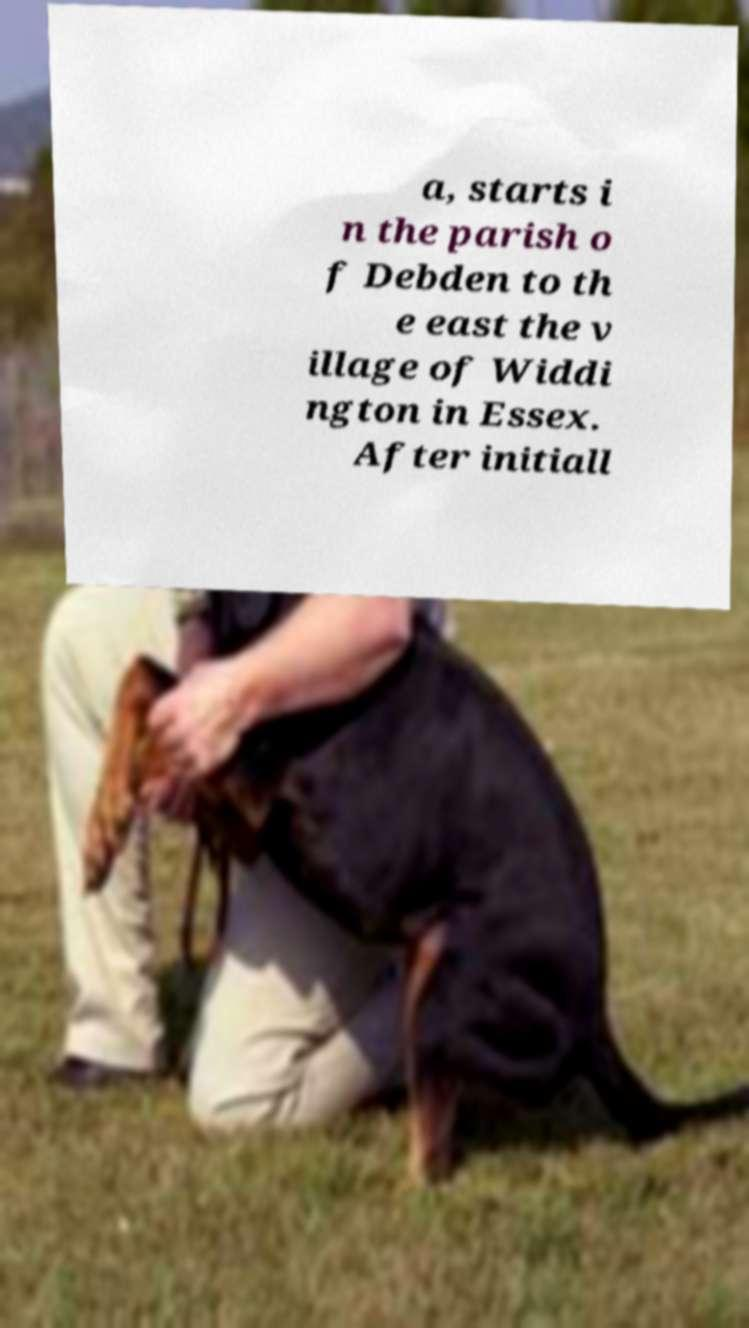What messages or text are displayed in this image? I need them in a readable, typed format. a, starts i n the parish o f Debden to th e east the v illage of Widdi ngton in Essex. After initiall 